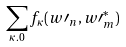<formula> <loc_0><loc_0><loc_500><loc_500>\sum _ { \kappa . 0 } f _ { \kappa } ( w \prime _ { n } , w \prime _ { m } ^ { \ast } )</formula> 